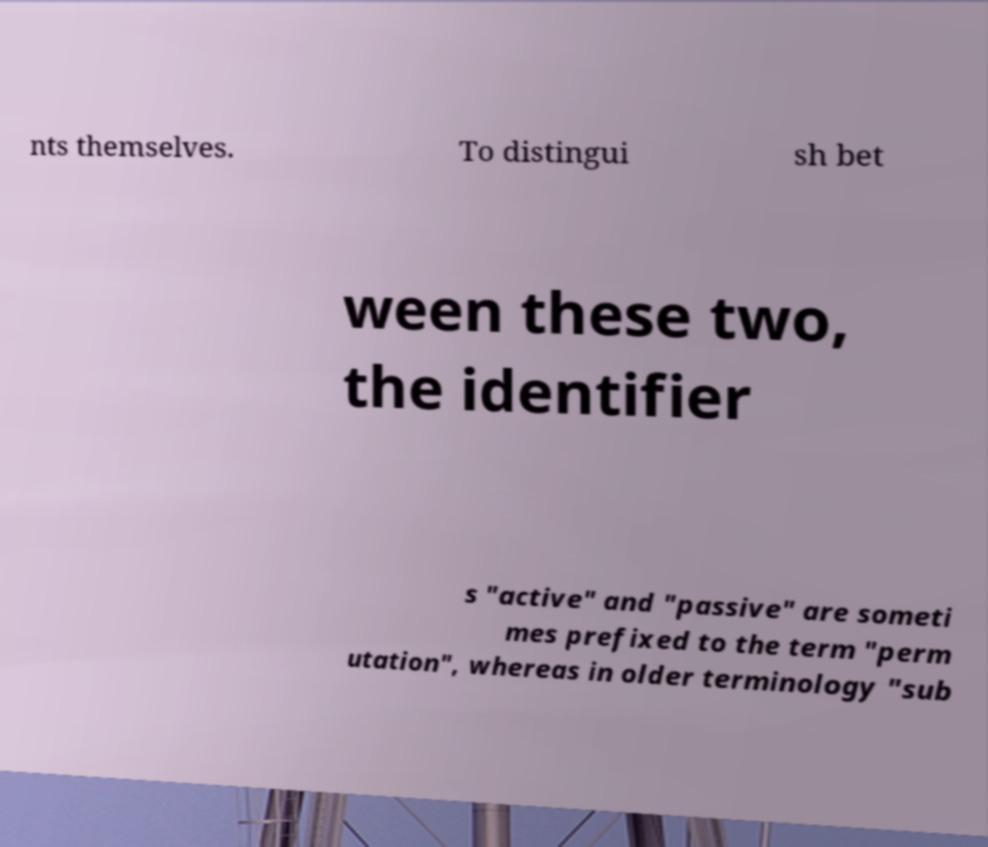For documentation purposes, I need the text within this image transcribed. Could you provide that? nts themselves. To distingui sh bet ween these two, the identifier s "active" and "passive" are someti mes prefixed to the term "perm utation", whereas in older terminology "sub 